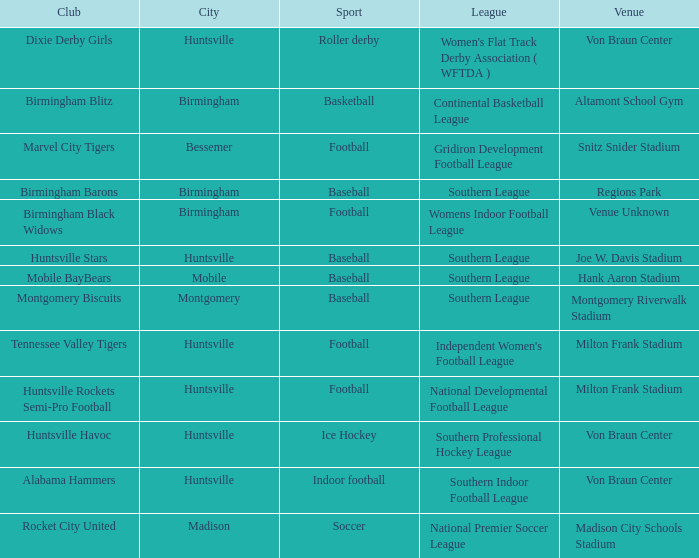Which sport had the club of the Montgomery Biscuits? Baseball. 